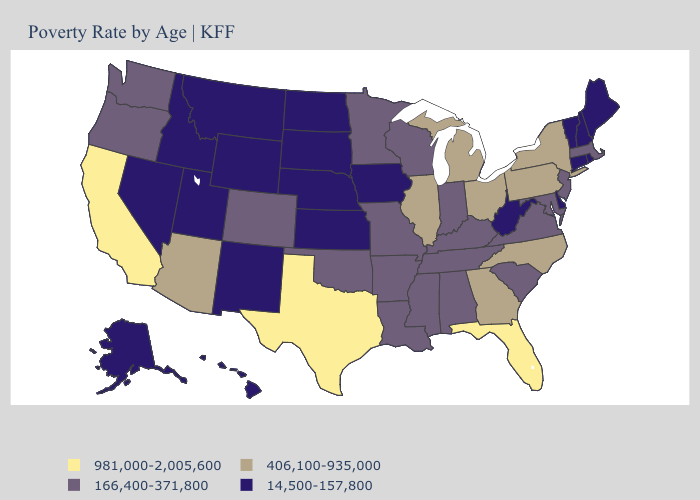What is the highest value in the Northeast ?
Concise answer only. 406,100-935,000. What is the lowest value in the South?
Give a very brief answer. 14,500-157,800. Name the states that have a value in the range 166,400-371,800?
Short answer required. Alabama, Arkansas, Colorado, Indiana, Kentucky, Louisiana, Maryland, Massachusetts, Minnesota, Mississippi, Missouri, New Jersey, Oklahoma, Oregon, South Carolina, Tennessee, Virginia, Washington, Wisconsin. Does Massachusetts have a higher value than Hawaii?
Concise answer only. Yes. What is the lowest value in the USA?
Concise answer only. 14,500-157,800. Which states hav the highest value in the West?
Keep it brief. California. Name the states that have a value in the range 981,000-2,005,600?
Short answer required. California, Florida, Texas. What is the value of Washington?
Keep it brief. 166,400-371,800. Name the states that have a value in the range 406,100-935,000?
Write a very short answer. Arizona, Georgia, Illinois, Michigan, New York, North Carolina, Ohio, Pennsylvania. Does Tennessee have a higher value than Alabama?
Quick response, please. No. Among the states that border Arkansas , does Tennessee have the lowest value?
Keep it brief. Yes. What is the value of Ohio?
Quick response, please. 406,100-935,000. Does New York have the same value as Virginia?
Short answer required. No. What is the lowest value in states that border South Dakota?
Quick response, please. 14,500-157,800. Name the states that have a value in the range 981,000-2,005,600?
Give a very brief answer. California, Florida, Texas. 